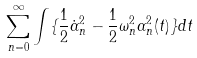Convert formula to latex. <formula><loc_0><loc_0><loc_500><loc_500>\sum _ { n = 0 } ^ { \infty } \int \{ \frac { 1 } { 2 } \dot { \alpha } _ { n } ^ { 2 } - \frac { 1 } { 2 } \omega _ { n } ^ { 2 } \alpha _ { n } ^ { 2 } ( t ) \} d t</formula> 